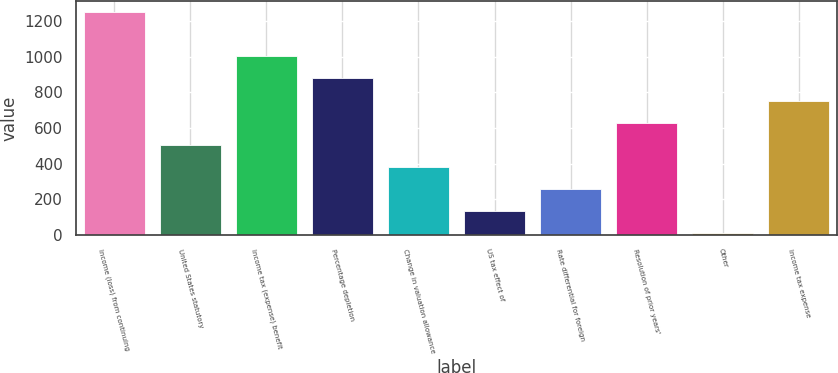Convert chart to OTSL. <chart><loc_0><loc_0><loc_500><loc_500><bar_chart><fcel>Income (loss) from continuing<fcel>United States statutory<fcel>Income tax (expense) benefit<fcel>Percentage depletion<fcel>Change in valuation allowance<fcel>US tax effect of<fcel>Rate differential for foreign<fcel>Resolution of prior years'<fcel>Other<fcel>Income tax expense<nl><fcel>1252<fcel>506.2<fcel>1003.4<fcel>879.1<fcel>381.9<fcel>133.3<fcel>257.6<fcel>630.5<fcel>9<fcel>754.8<nl></chart> 